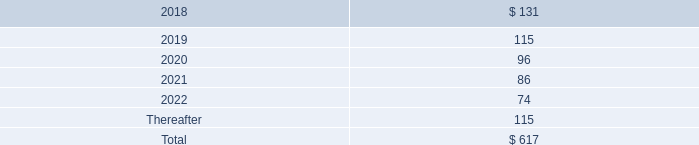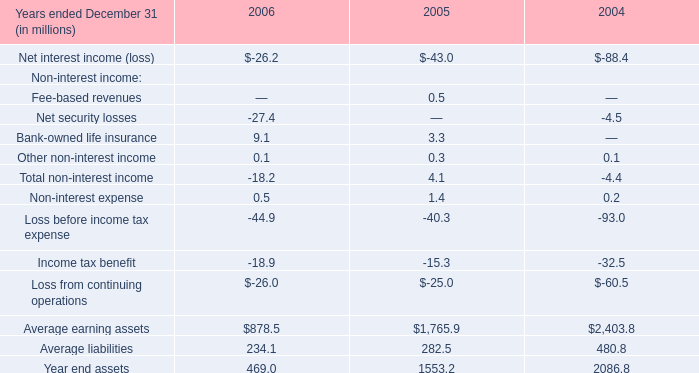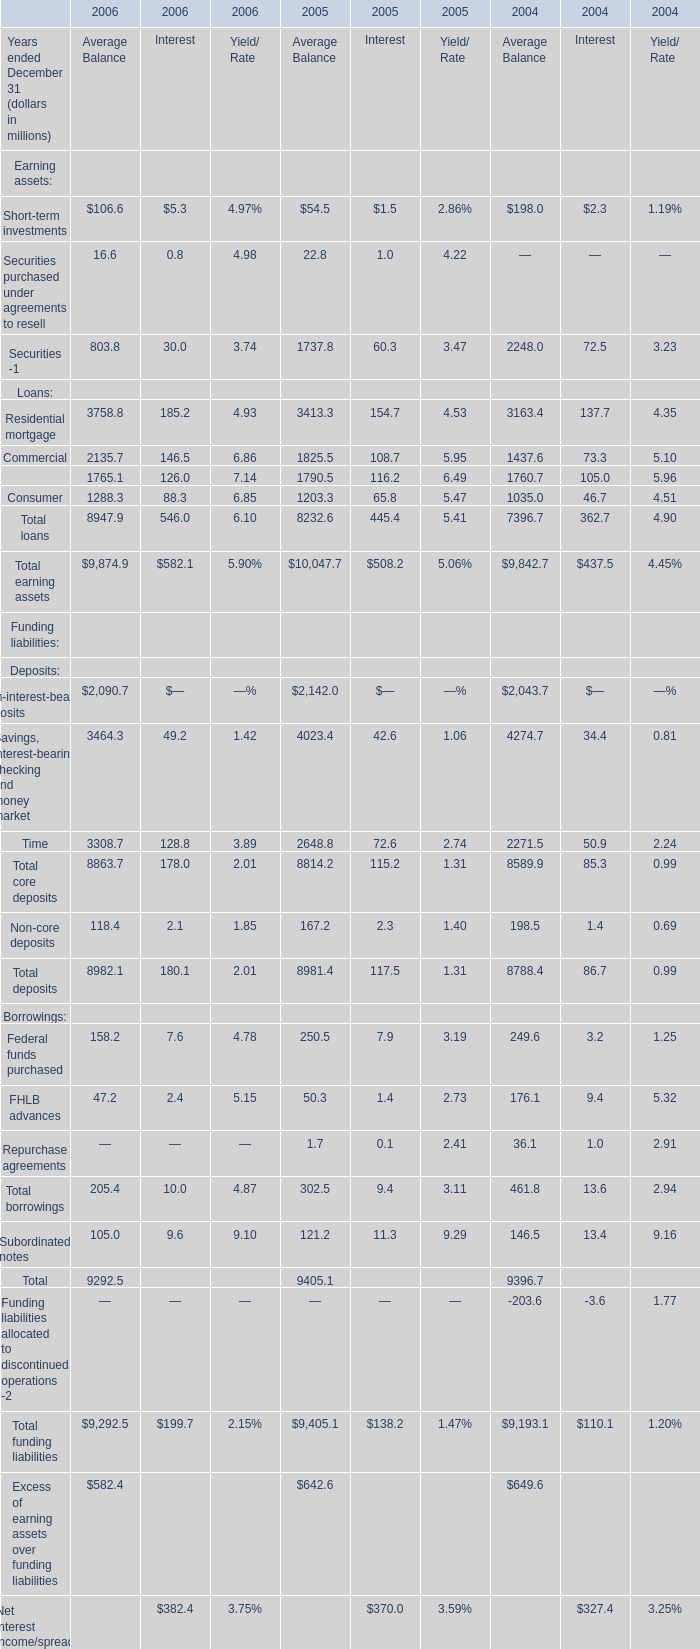Which year is Average Balance of Total earning assets the highest? 
Answer: 2005. 